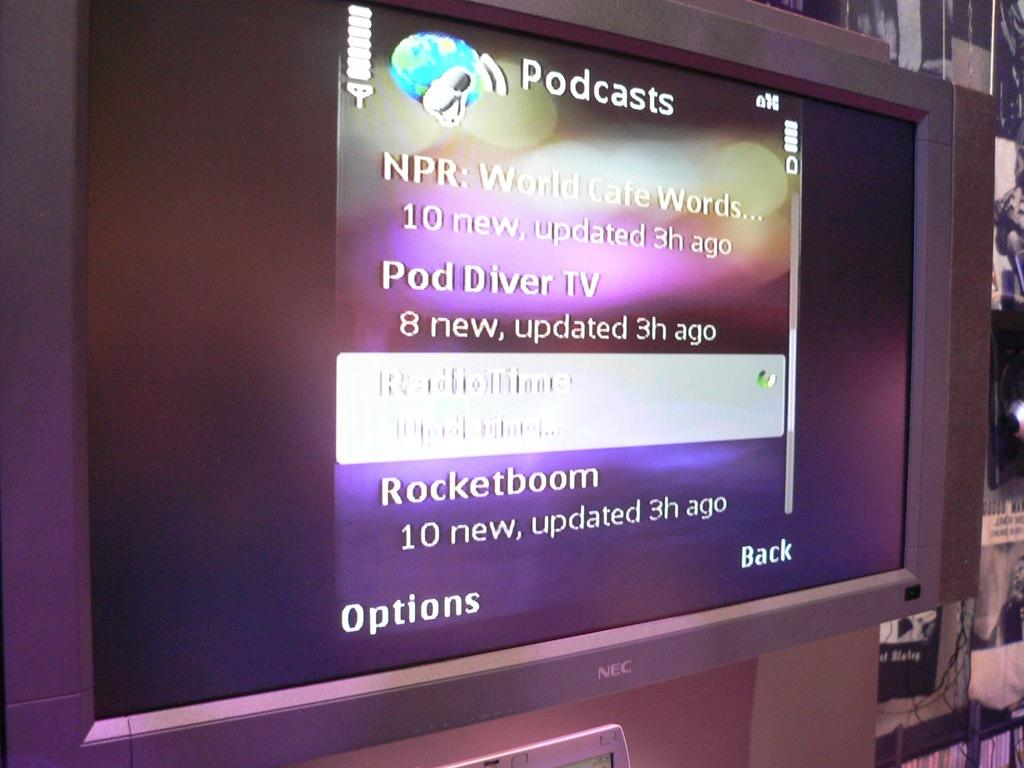<image>
Write a terse but informative summary of the picture. On a large monitor there is a list of Podcasts. 